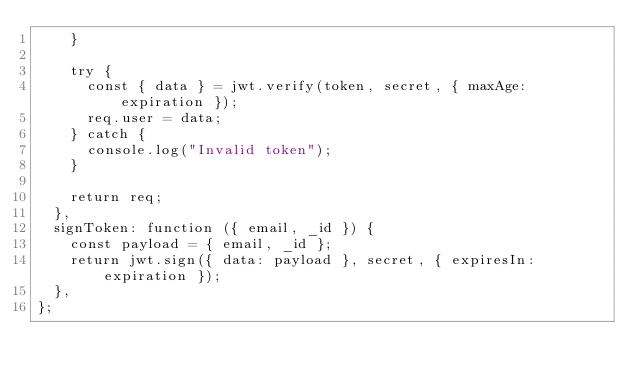<code> <loc_0><loc_0><loc_500><loc_500><_JavaScript_>    }

    try {
      const { data } = jwt.verify(token, secret, { maxAge: expiration });
      req.user = data;
    } catch {
      console.log("Invalid token");
    }

    return req;
  },
  signToken: function ({ email, _id }) {
    const payload = { email, _id };
    return jwt.sign({ data: payload }, secret, { expiresIn: expiration });
  },
};
</code> 